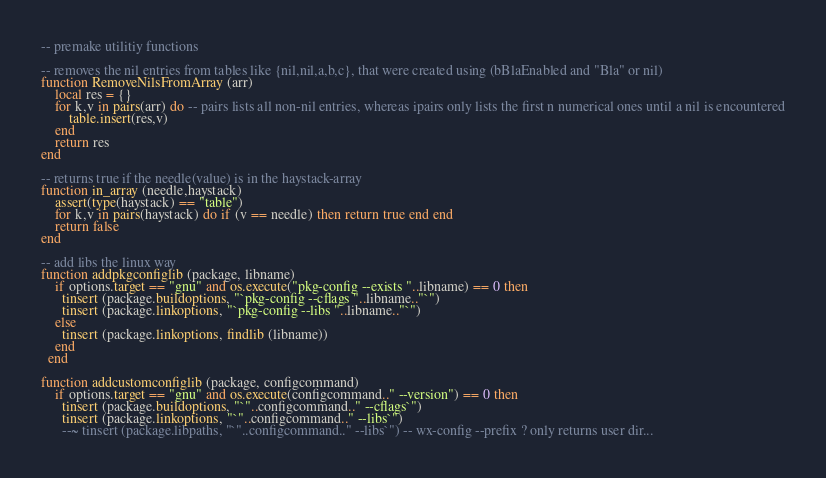Convert code to text. <code><loc_0><loc_0><loc_500><loc_500><_Lua_>-- premake utilitiy functions

-- removes the nil entries from tables like {nil,nil,a,b,c}, that were created using (bBlaEnabled and "Bla" or nil)
function RemoveNilsFromArray (arr) 
	local res = {}
	for k,v in pairs(arr) do -- pairs lists all non-nil entries, whereas ipairs only lists the first n numerical ones until a nil is encountered
		table.insert(res,v) 
	end
	return res
end

-- returns true if the needle(value) is in the haystack-array
function in_array (needle,haystack) 
	assert(type(haystack) == "table")
	for k,v in pairs(haystack) do if (v == needle) then return true end end
	return false
end

-- add libs the linux way
function addpkgconfiglib (package, libname)
    if options.target == "gnu" and os.execute("pkg-config --exists "..libname) == 0 then
      tinsert (package.buildoptions, "`pkg-config --cflags "..libname.."`")
      tinsert (package.linkoptions, "`pkg-config --libs "..libname.."`")
    else
      tinsert (package.linkoptions, findlib (libname))
    end
  end

function addcustomconfiglib (package, configcommand)
    if options.target == "gnu" and os.execute(configcommand.." --version") == 0 then
      tinsert (package.buildoptions, "`"..configcommand.." --cflags`")
      tinsert (package.linkoptions, "`"..configcommand.." --libs`")
      --~ tinsert (package.libpaths, "`"..configcommand.." --libs`") -- wx-config --prefix ? only returns user dir...</code> 